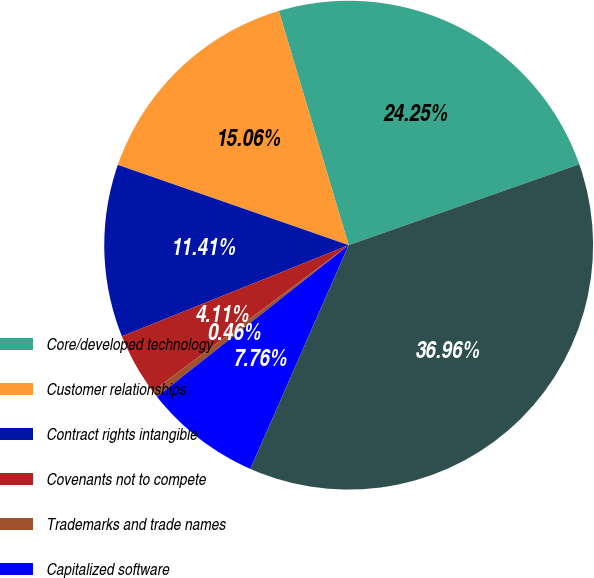<chart> <loc_0><loc_0><loc_500><loc_500><pie_chart><fcel>Core/developed technology<fcel>Customer relationships<fcel>Contract rights intangible<fcel>Covenants not to compete<fcel>Trademarks and trade names<fcel>Capitalized software<fcel>Total<nl><fcel>24.25%<fcel>15.06%<fcel>11.41%<fcel>4.11%<fcel>0.46%<fcel>7.76%<fcel>36.96%<nl></chart> 